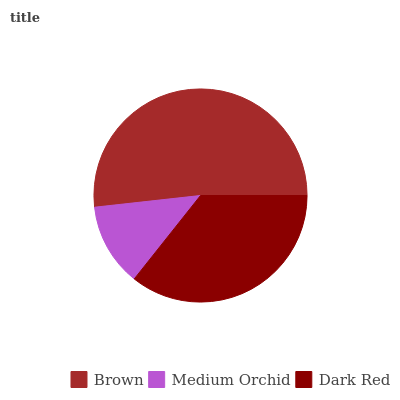Is Medium Orchid the minimum?
Answer yes or no. Yes. Is Brown the maximum?
Answer yes or no. Yes. Is Dark Red the minimum?
Answer yes or no. No. Is Dark Red the maximum?
Answer yes or no. No. Is Dark Red greater than Medium Orchid?
Answer yes or no. Yes. Is Medium Orchid less than Dark Red?
Answer yes or no. Yes. Is Medium Orchid greater than Dark Red?
Answer yes or no. No. Is Dark Red less than Medium Orchid?
Answer yes or no. No. Is Dark Red the high median?
Answer yes or no. Yes. Is Dark Red the low median?
Answer yes or no. Yes. Is Brown the high median?
Answer yes or no. No. Is Brown the low median?
Answer yes or no. No. 